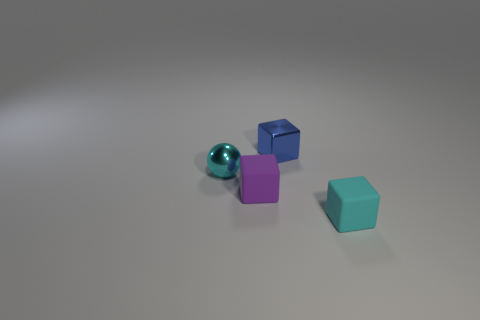There is a cyan object that is made of the same material as the purple thing; what size is it?
Your answer should be compact. Small. There is a small matte object behind the cyan rubber object; does it have the same shape as the blue thing?
Make the answer very short. Yes. What is the size of the rubber cube that is the same color as the tiny metallic ball?
Your answer should be very brief. Small. How many purple objects are small shiny balls or rubber balls?
Provide a short and direct response. 0. How many other objects are the same shape as the blue thing?
Make the answer very short. 2. There is a small object that is both in front of the cyan metallic sphere and on the left side of the tiny blue metal cube; what is its shape?
Keep it short and to the point. Cube. There is a tiny blue cube; are there any balls to the right of it?
Offer a terse response. No. The cyan rubber object that is the same shape as the small blue shiny object is what size?
Your answer should be very brief. Small. Is there anything else that has the same size as the blue object?
Make the answer very short. Yes. Is the purple matte thing the same shape as the small blue object?
Provide a succinct answer. Yes. 